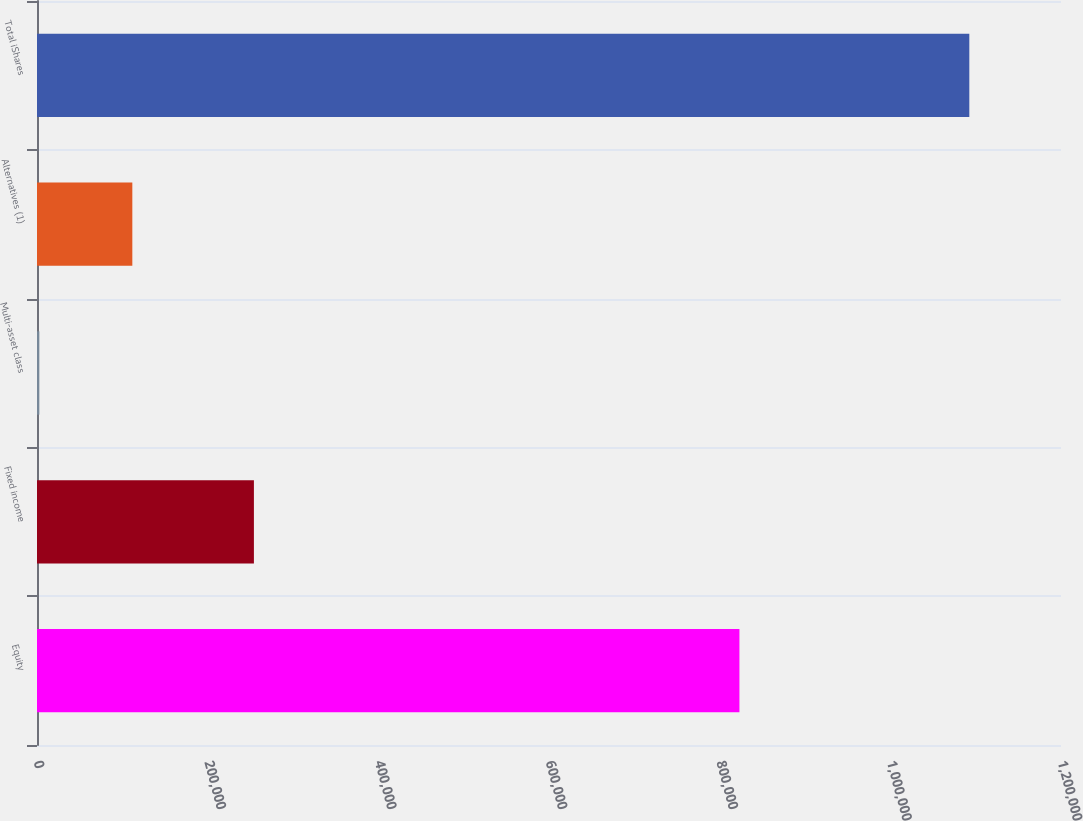Convert chart to OTSL. <chart><loc_0><loc_0><loc_500><loc_500><bar_chart><fcel>Equity<fcel>Fixed income<fcel>Multi-asset class<fcel>Alternatives (1)<fcel>Total iShares<nl><fcel>823156<fcel>254190<fcel>2730<fcel>111713<fcel>1.09256e+06<nl></chart> 